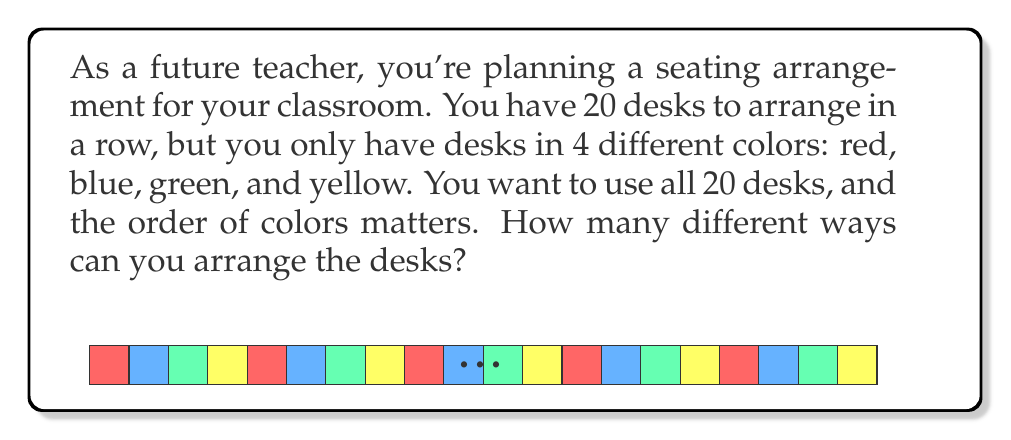Give your solution to this math problem. Let's approach this step-by-step:

1) This is a permutation with repetition problem. We have 20 positions to fill (the desks), and 4 choices (colors) for each position.

2) In a permutation with repetition, the formula is:

   $$n^r$$

   where $n$ is the number of choices for each position, and $r$ is the number of positions.

3) In this case:
   $n = 4$ (4 colors to choose from)
   $r = 20$ (20 desks to arrange)

4) Plugging these values into our formula:

   $$4^{20}$$

5) We can calculate this:

   $$4^{20} = 1,099,511,627,776$$

This means there are 1,099,511,627,776 different ways to arrange the 20 desks using the 4 colors.
Answer: $4^{20} = 1,099,511,627,776$ 